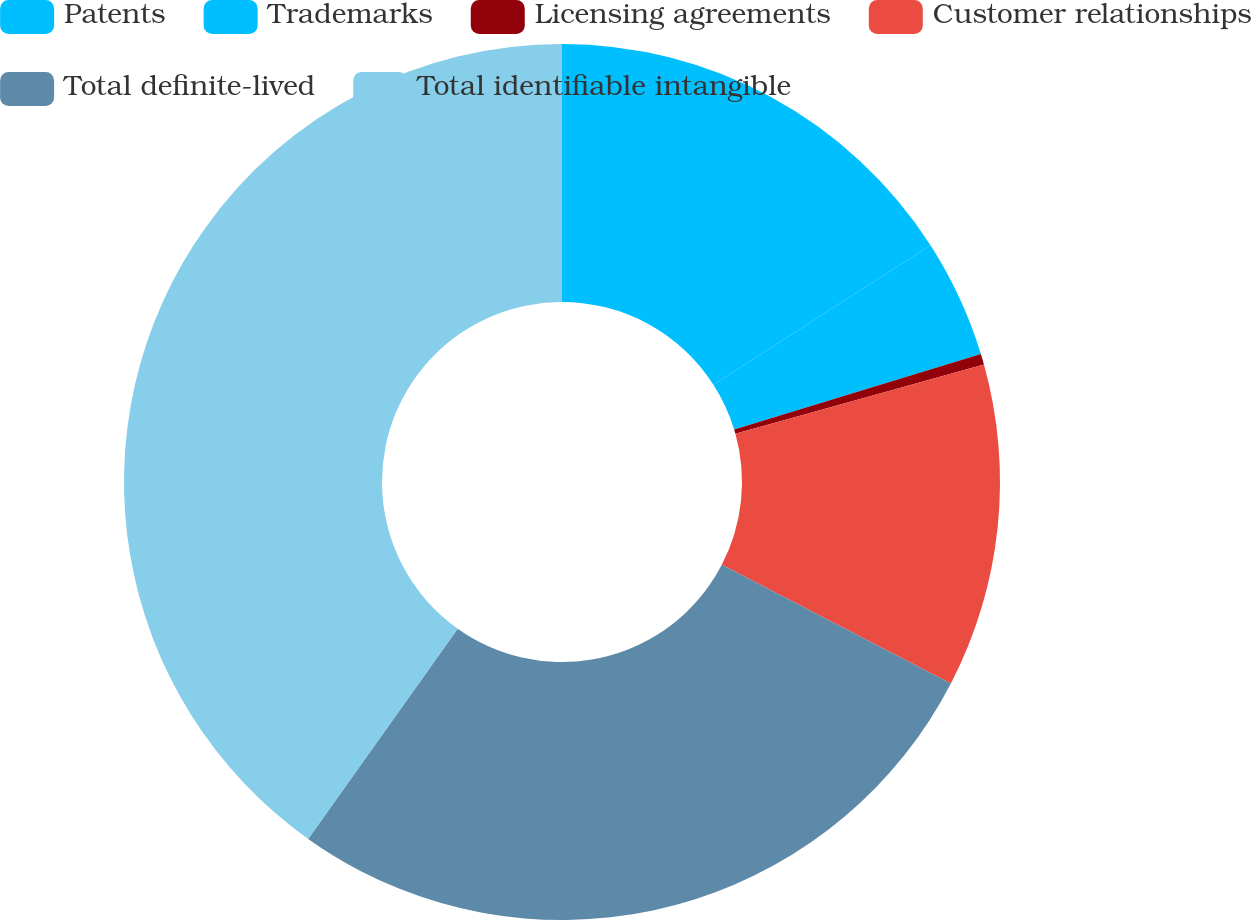Convert chart. <chart><loc_0><loc_0><loc_500><loc_500><pie_chart><fcel>Patents<fcel>Trademarks<fcel>Licensing agreements<fcel>Customer relationships<fcel>Total definite-lived<fcel>Total identifiable intangible<nl><fcel>15.91%<fcel>4.37%<fcel>0.4%<fcel>11.93%<fcel>27.23%<fcel>40.16%<nl></chart> 